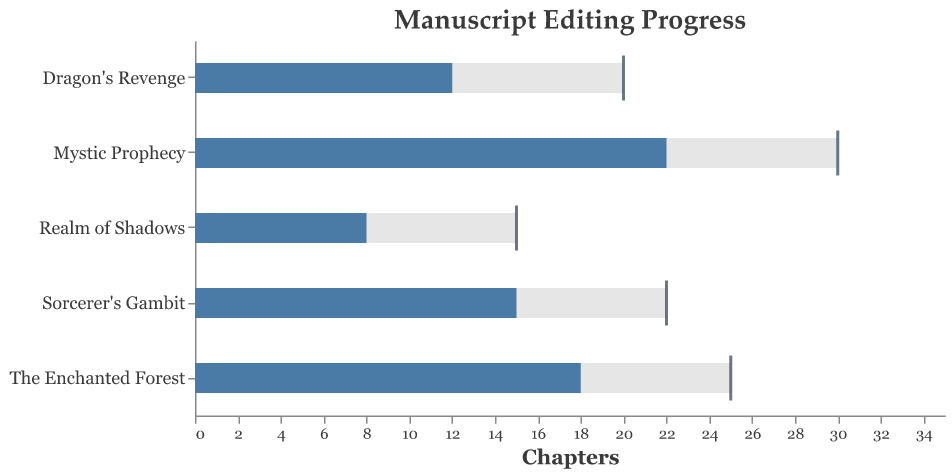What is the title of the chart? The title of the chart is visually set at the top and indicates the main topic of the graph.
Answer: Manuscript Editing Progress How many chapters are planned for Mystic Prophecy? Look at the bar representing "Mystic Prophecy" to find the value on the x-axis labeled "Planned."
Answer: 30 Which manuscript has the highest number of completed chapters? Compare the lengths of the "Completed" bars for each manuscript and find the longest one.
Answer: Mystic Prophecy What is the main color used to show the completed chapters? Review the bar color used to represent the "Completed" chapters.
Answer: Blue What is the difference in completed chapters between Dragon's Revenge and Sorcerer's Gambit? Subtract the number of chapters completed for Dragon's Revenge (12) from those completed for Sorcerer's Gambit (15). 15 - 12 = 3
Answer: 3 How many manuscripts have their goal chapters completed? Identify the manuscripts where the tick representing "Goal" aligns with the end of the "Completed" bar.
Answer: None of the manuscripts What is the sum of planned chapters for "The Enchanted Forest" and "Realm of Shadows"? Add the planned chapters for "The Enchanted Forest" (25) and "Realm of Shadows" (15). 25 + 15 = 40
Answer: 40 Which manuscript is closest to its planned chapters but not completed? Compare completed chapters to planned chapters for each manuscript and find the smallest remaining difference where chapters are not fully completed.
Answer: The Enchanted Forest How much more progress is needed for Realm of Shadows to reach its planned chapters? Subtract the completed chapters of "Realm of Shadows" (8) from its planned chapters (15). 15 - 8 = 7
Answer: 7 Which manuscript has its completed chapters farthest from its goal chapters? Calculate the difference between completed and goal chapters for each manuscript and find the one with the largest difference.
Answer: Mystic Prophecy 